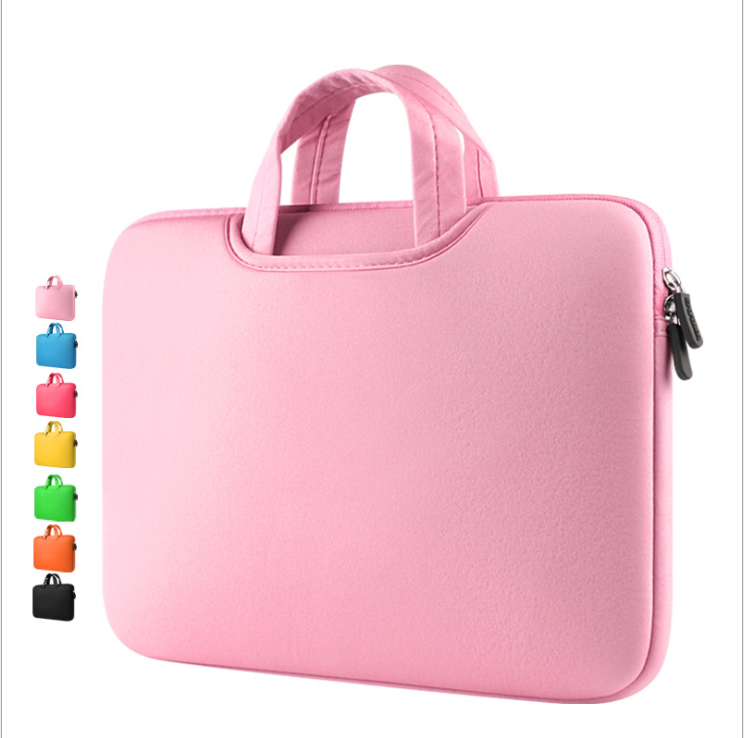Can you explain how the design of this laptop sleeve might contribute to its functionality? Certainly! The design of the laptop sleeve emphasizes simplicity and functionality. Its clean, rectangular shape is designed to snugly fit standard laptop sizes, maximizing protection without excess material. The smooth exterior, lacking excessive adornments, minimizes the risk of catching on other objects, making it more convenient to carry or slide into a bag. The inclusion of a robust zipper ensures that the device remains securely enclosed, protecting it from dust and accidental drops out of the sleeve. Is there anything specific about the zipper design that enhances the sleeve's functionality? Yes, the zipper includes a large, sturdy pull that is easy to grasp, enhancing usability for quick access. It runs smoothly along the sides, allowing for a wide opening which makes it easier to insert or remove a laptop. The design likely features a padded zipper closure that prevents the laptop from being scratched by the zipper itself during use, showcasing a thoughtful consideration of everyday functional reliability and user experience. 